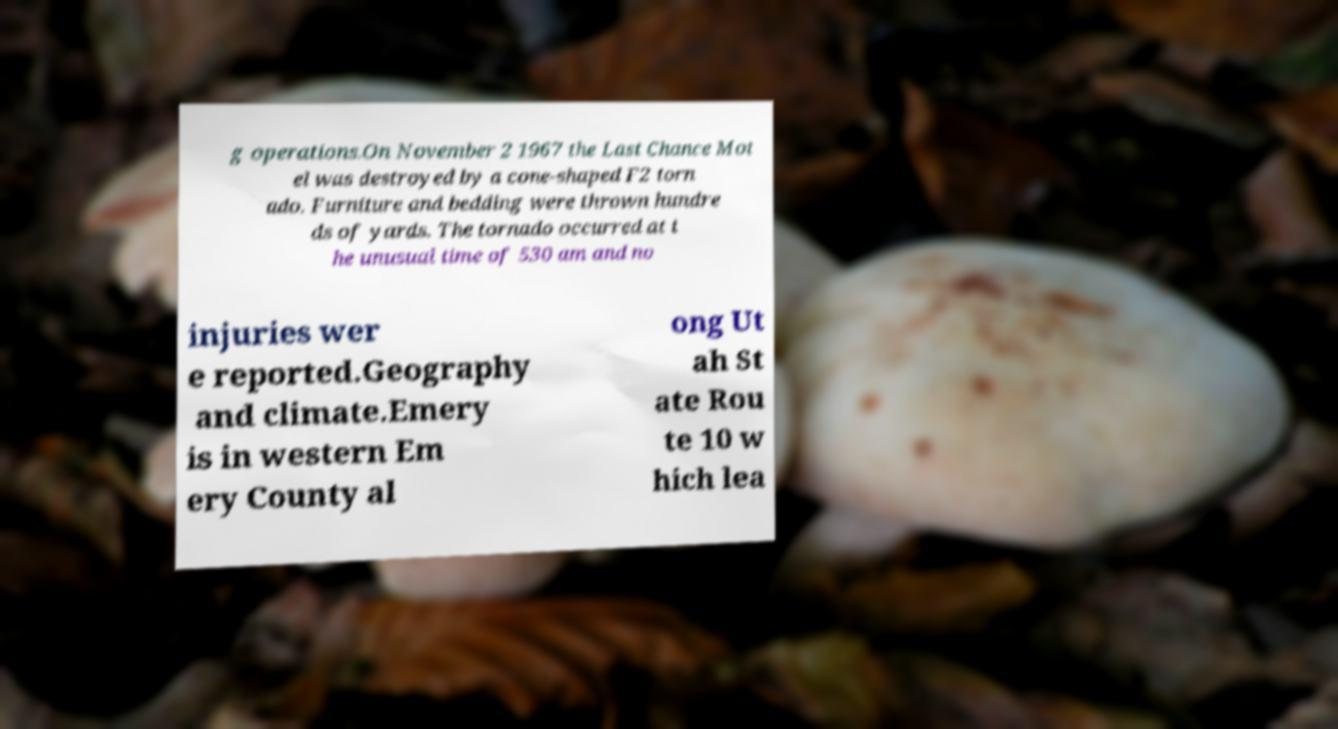Please read and relay the text visible in this image. What does it say? g operations.On November 2 1967 the Last Chance Mot el was destroyed by a cone-shaped F2 torn ado. Furniture and bedding were thrown hundre ds of yards. The tornado occurred at t he unusual time of 530 am and no injuries wer e reported.Geography and climate.Emery is in western Em ery County al ong Ut ah St ate Rou te 10 w hich lea 